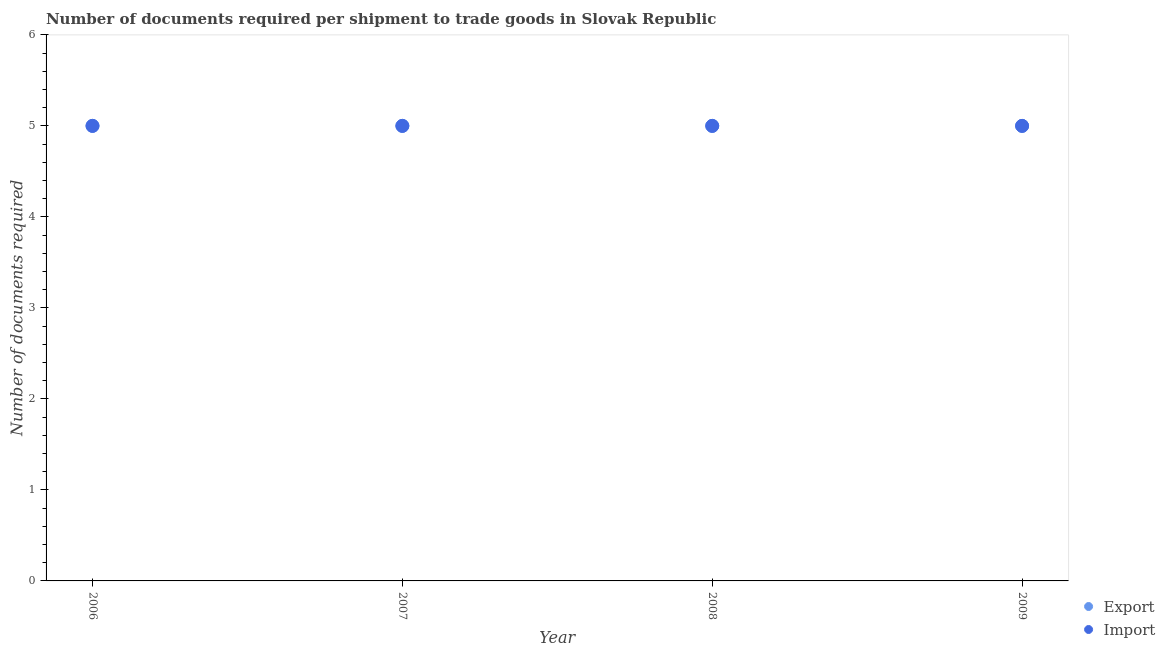How many different coloured dotlines are there?
Give a very brief answer. 2. What is the number of documents required to export goods in 2006?
Your answer should be compact. 5. Across all years, what is the maximum number of documents required to import goods?
Keep it short and to the point. 5. Across all years, what is the minimum number of documents required to export goods?
Your response must be concise. 5. What is the total number of documents required to export goods in the graph?
Your answer should be very brief. 20. What is the difference between the number of documents required to import goods in 2007 and that in 2008?
Offer a very short reply. 0. What is the difference between the number of documents required to export goods in 2007 and the number of documents required to import goods in 2009?
Provide a short and direct response. 0. In the year 2009, what is the difference between the number of documents required to export goods and number of documents required to import goods?
Offer a very short reply. 0. In how many years, is the number of documents required to export goods greater than 3.6?
Provide a succinct answer. 4. What is the difference between the highest and the second highest number of documents required to export goods?
Make the answer very short. 0. What is the difference between the highest and the lowest number of documents required to import goods?
Give a very brief answer. 0. In how many years, is the number of documents required to import goods greater than the average number of documents required to import goods taken over all years?
Your answer should be compact. 0. Is the sum of the number of documents required to import goods in 2007 and 2008 greater than the maximum number of documents required to export goods across all years?
Make the answer very short. Yes. Does the number of documents required to export goods monotonically increase over the years?
Give a very brief answer. No. Is the number of documents required to import goods strictly greater than the number of documents required to export goods over the years?
Your answer should be very brief. No. How many years are there in the graph?
Your answer should be compact. 4. What is the difference between two consecutive major ticks on the Y-axis?
Offer a terse response. 1. Are the values on the major ticks of Y-axis written in scientific E-notation?
Keep it short and to the point. No. Does the graph contain any zero values?
Make the answer very short. No. Where does the legend appear in the graph?
Make the answer very short. Bottom right. How many legend labels are there?
Keep it short and to the point. 2. What is the title of the graph?
Provide a succinct answer. Number of documents required per shipment to trade goods in Slovak Republic. What is the label or title of the Y-axis?
Provide a short and direct response. Number of documents required. What is the Number of documents required of Export in 2006?
Make the answer very short. 5. What is the Number of documents required in Import in 2006?
Your response must be concise. 5. What is the Number of documents required of Export in 2007?
Give a very brief answer. 5. What is the Number of documents required of Import in 2007?
Offer a terse response. 5. What is the Number of documents required of Export in 2008?
Offer a terse response. 5. What is the Number of documents required of Export in 2009?
Your answer should be very brief. 5. What is the Number of documents required in Import in 2009?
Offer a terse response. 5. Across all years, what is the maximum Number of documents required of Import?
Offer a very short reply. 5. What is the total Number of documents required in Export in the graph?
Make the answer very short. 20. What is the total Number of documents required of Import in the graph?
Your answer should be very brief. 20. What is the difference between the Number of documents required of Export in 2006 and that in 2007?
Offer a very short reply. 0. What is the difference between the Number of documents required in Import in 2006 and that in 2007?
Your response must be concise. 0. What is the difference between the Number of documents required of Import in 2006 and that in 2008?
Offer a terse response. 0. What is the difference between the Number of documents required in Export in 2006 and that in 2009?
Your answer should be very brief. 0. What is the difference between the Number of documents required in Import in 2007 and that in 2008?
Your response must be concise. 0. What is the difference between the Number of documents required of Export in 2007 and that in 2009?
Make the answer very short. 0. What is the difference between the Number of documents required of Import in 2007 and that in 2009?
Make the answer very short. 0. What is the difference between the Number of documents required of Export in 2008 and that in 2009?
Your answer should be very brief. 0. What is the difference between the Number of documents required in Import in 2008 and that in 2009?
Keep it short and to the point. 0. What is the difference between the Number of documents required of Export in 2007 and the Number of documents required of Import in 2009?
Provide a succinct answer. 0. What is the difference between the Number of documents required in Export in 2008 and the Number of documents required in Import in 2009?
Provide a succinct answer. 0. In the year 2006, what is the difference between the Number of documents required in Export and Number of documents required in Import?
Provide a short and direct response. 0. In the year 2008, what is the difference between the Number of documents required in Export and Number of documents required in Import?
Provide a succinct answer. 0. What is the ratio of the Number of documents required in Export in 2006 to that in 2009?
Offer a terse response. 1. What is the ratio of the Number of documents required in Import in 2007 to that in 2008?
Provide a succinct answer. 1. What is the ratio of the Number of documents required in Export in 2007 to that in 2009?
Your response must be concise. 1. What is the ratio of the Number of documents required of Import in 2007 to that in 2009?
Ensure brevity in your answer.  1. What is the difference between the highest and the second highest Number of documents required of Export?
Your answer should be very brief. 0. 